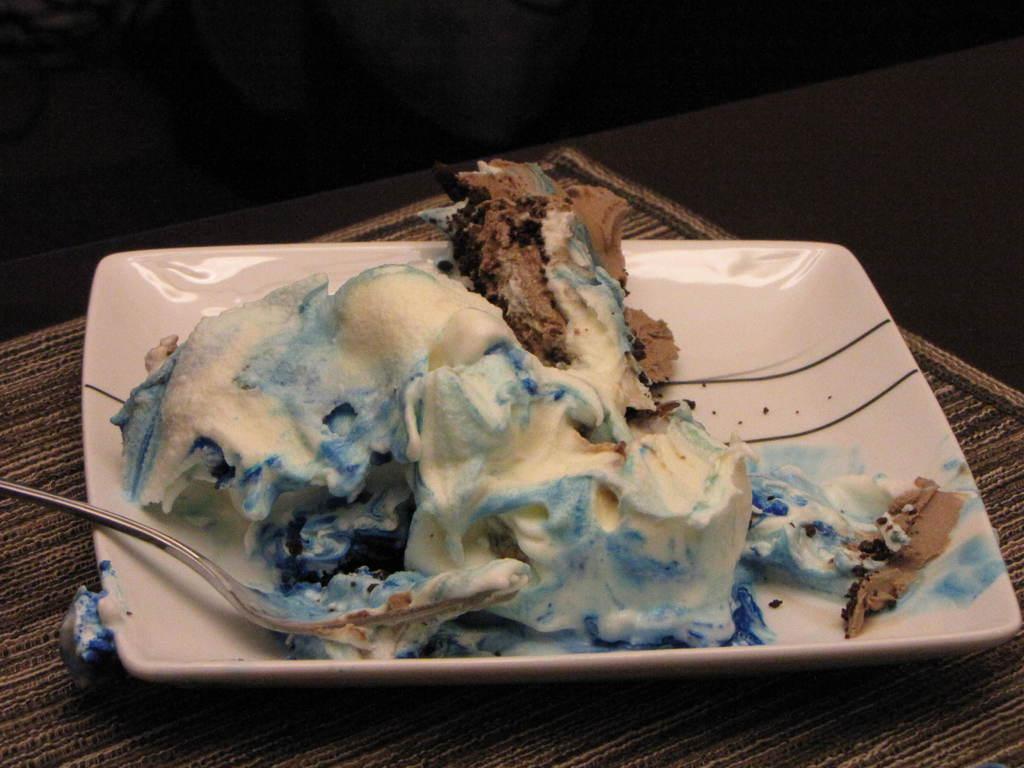Can you describe this image briefly? Here in this picture we can see a pastry cake present on a plate, which is present on the table over there and we can also see a spoon on it over there. 